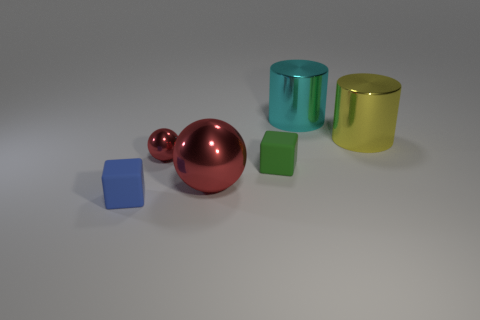Does the cylinder in front of the large cyan metallic cylinder have the same material as the red ball that is behind the small green matte object?
Offer a very short reply. Yes. There is a thing that is both behind the small red metal sphere and on the left side of the yellow thing; what material is it?
Give a very brief answer. Metal. Do the tiny green object and the shiny object on the left side of the large red sphere have the same shape?
Give a very brief answer. No. What is the large cyan cylinder that is on the right side of the sphere that is in front of the tiny matte block that is behind the tiny blue block made of?
Your answer should be very brief. Metal. How many other things are there of the same size as the blue rubber block?
Your response must be concise. 2. Is the color of the small shiny ball the same as the large metal sphere?
Keep it short and to the point. Yes. How many small cubes are on the left side of the big thing to the left of the large metal cylinder behind the big yellow metal thing?
Offer a terse response. 1. What material is the block in front of the large metallic object that is to the left of the cyan object made of?
Provide a short and direct response. Rubber. Is there a big cyan metal object that has the same shape as the big red shiny object?
Ensure brevity in your answer.  No. What is the color of the cylinder that is the same size as the cyan thing?
Your answer should be very brief. Yellow. 